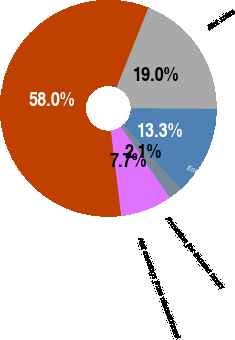<chart> <loc_0><loc_0><loc_500><loc_500><pie_chart><fcel>Dollars in Millions<fcel>Net sales<fcel>Earnings before incomes taxes<fcel>Provision for income taxes<fcel>Net earnings from discontinued<nl><fcel>57.97%<fcel>19.02%<fcel>13.26%<fcel>2.08%<fcel>7.67%<nl></chart> 